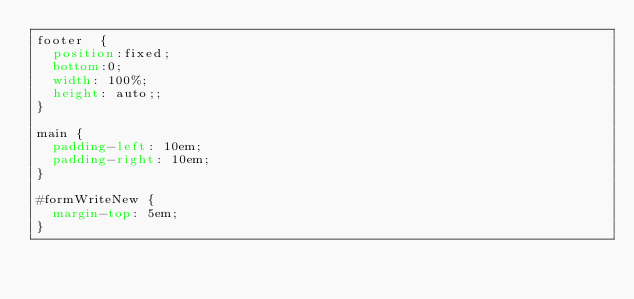Convert code to text. <code><loc_0><loc_0><loc_500><loc_500><_CSS_>footer  {
  position:fixed;
  bottom:0;
  width: 100%;
  height: auto;;
}

main {
  padding-left: 10em;
  padding-right: 10em;
}

#formWriteNew {
  margin-top: 5em;
}
</code> 